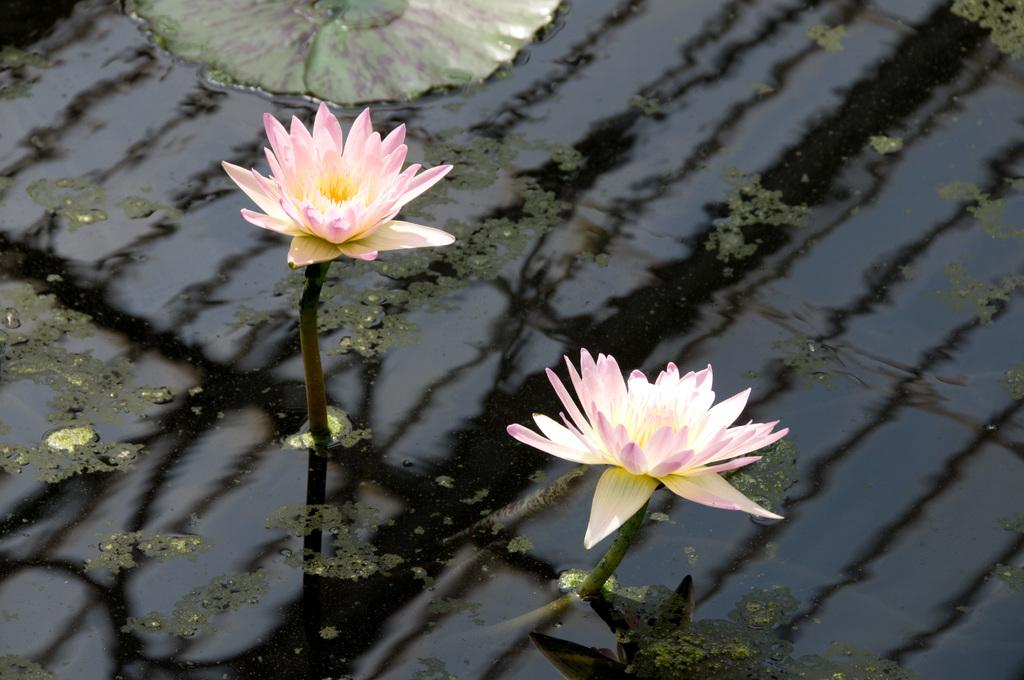How many lotus flowers can be seen in the image? There are two lotus flowers in the image. What else is floating on the water in the image? There is a leaf floating on the water in the image. What is the primary element visible in the image? The water is visible in the image. What type of throne is depicted in the image? There is no throne present in the image; it features two lotus flowers and a floating leaf on water. What act is being performed by the lotus flowers in the image? Lotus flowers do not perform acts; they are stationary plants in the image. 